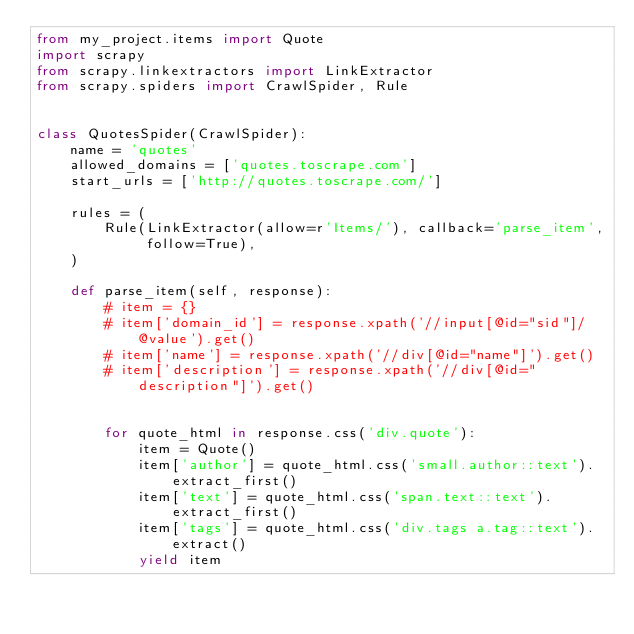Convert code to text. <code><loc_0><loc_0><loc_500><loc_500><_Python_>from my_project.items import Quote
import scrapy
from scrapy.linkextractors import LinkExtractor
from scrapy.spiders import CrawlSpider, Rule


class QuotesSpider(CrawlSpider):
    name = 'quotes'
    allowed_domains = ['quotes.toscrape.com']
    start_urls = ['http://quotes.toscrape.com/']

    rules = (
        Rule(LinkExtractor(allow=r'Items/'), callback='parse_item', follow=True),
    )

    def parse_item(self, response):
        # item = {}
        # item['domain_id'] = response.xpath('//input[@id="sid"]/@value').get()
        # item['name'] = response.xpath('//div[@id="name"]').get()
        # item['description'] = response.xpath('//div[@id="description"]').get()


        for quote_html in response.css('div.quote'):
            item = Quote()
            item['author'] = quote_html.css('small.author::text').extract_first()
            item['text'] = quote_html.css('span.text::text').extract_first()
            item['tags'] = quote_html.css('div.tags a.tag::text').extract()
            yield item</code> 